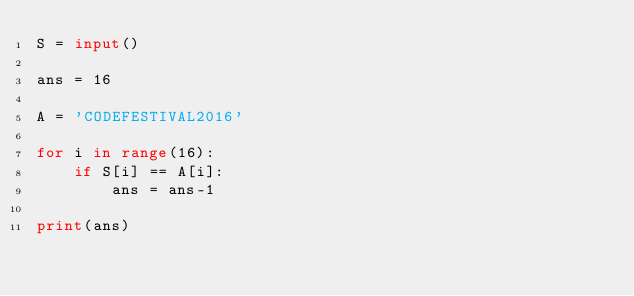Convert code to text. <code><loc_0><loc_0><loc_500><loc_500><_Python_>S = input()

ans = 16

A = 'CODEFESTIVAL2016'

for i in range(16):
    if S[i] == A[i]:
        ans = ans-1
        
print(ans)</code> 